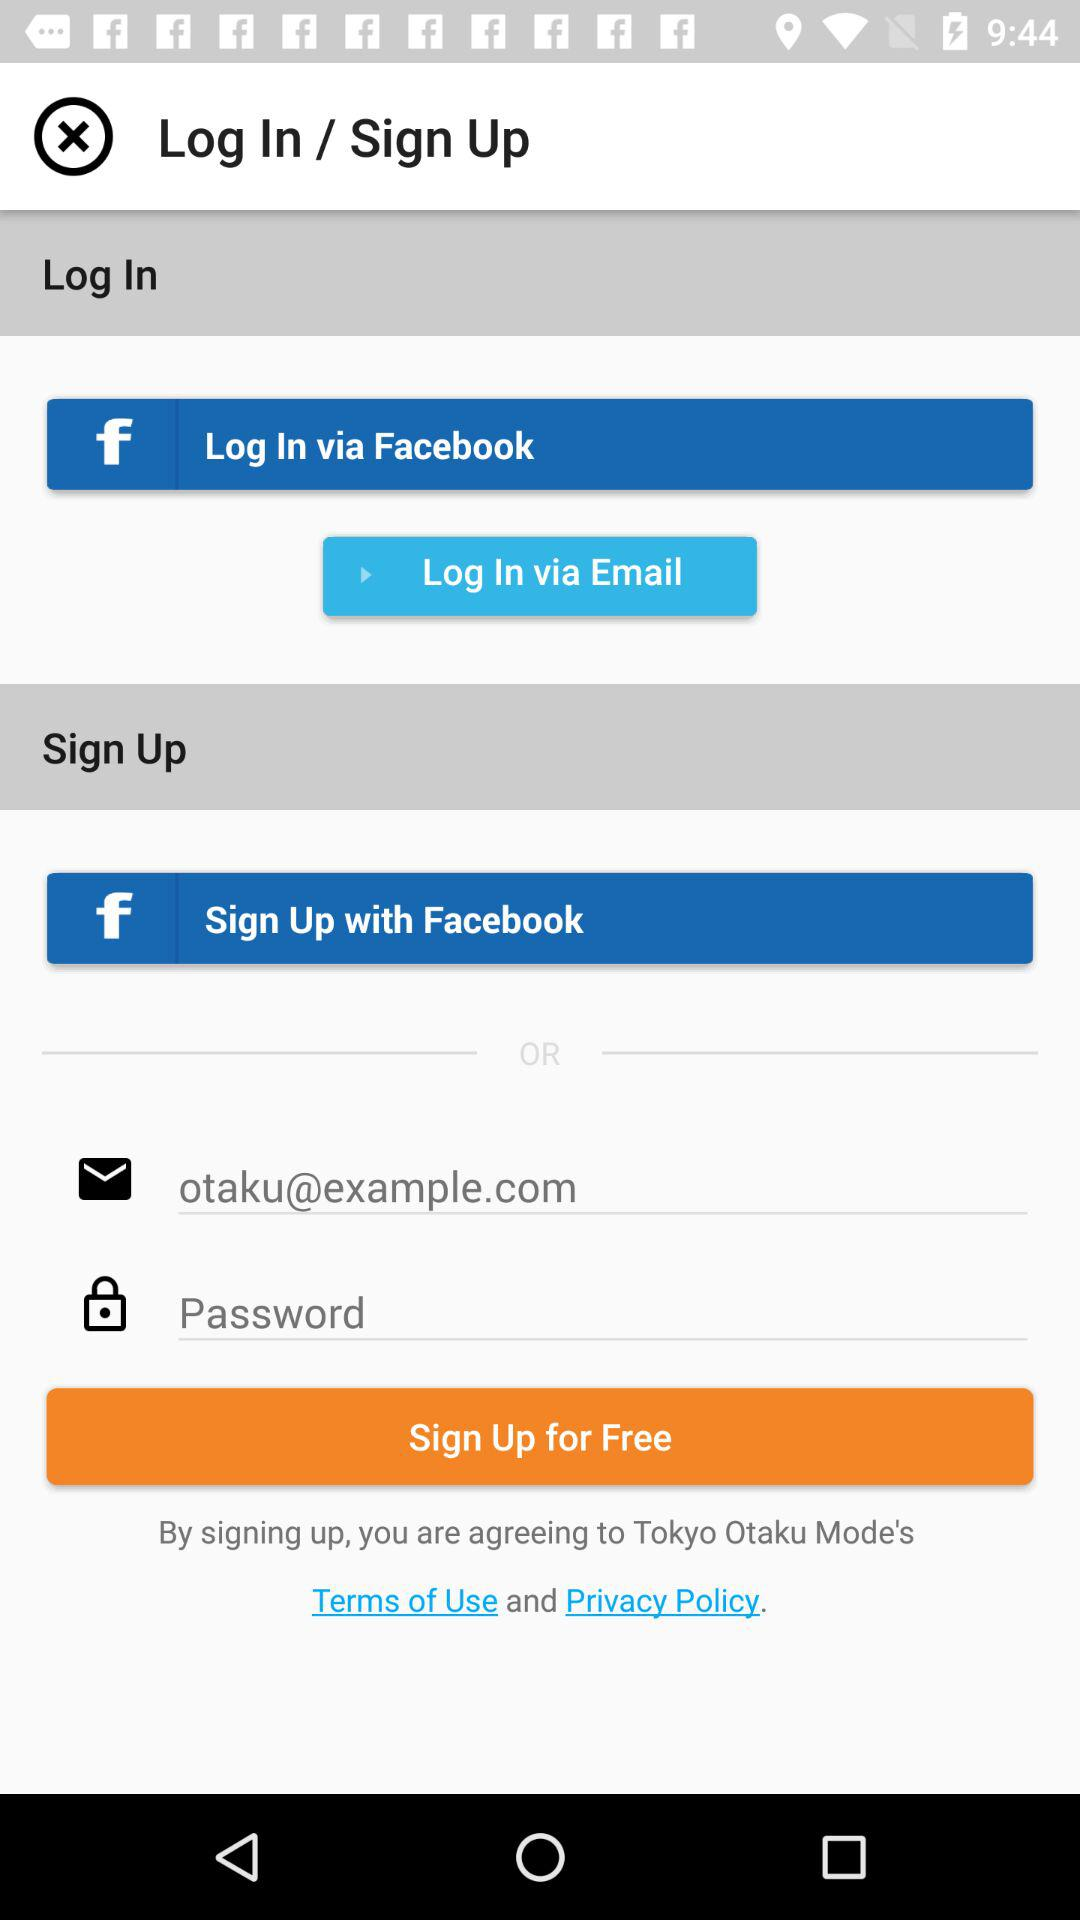What is the email address? The email address is otaku@example.com. 